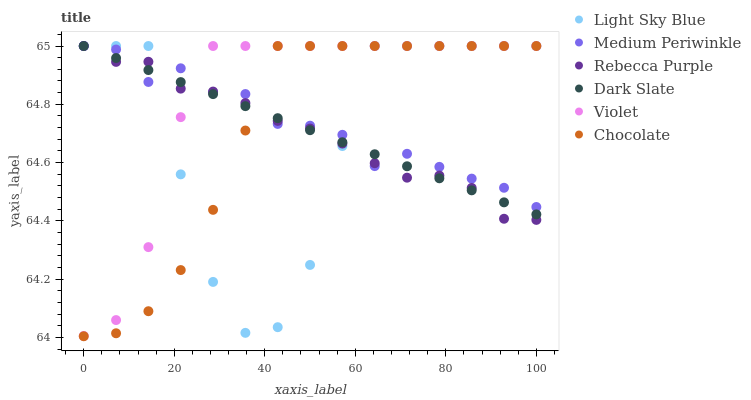Does Light Sky Blue have the minimum area under the curve?
Answer yes or no. Yes. Does Violet have the maximum area under the curve?
Answer yes or no. Yes. Does Chocolate have the minimum area under the curve?
Answer yes or no. No. Does Chocolate have the maximum area under the curve?
Answer yes or no. No. Is Dark Slate the smoothest?
Answer yes or no. Yes. Is Light Sky Blue the roughest?
Answer yes or no. Yes. Is Chocolate the smoothest?
Answer yes or no. No. Is Chocolate the roughest?
Answer yes or no. No. Does Chocolate have the lowest value?
Answer yes or no. Yes. Does Dark Slate have the lowest value?
Answer yes or no. No. Does Violet have the highest value?
Answer yes or no. Yes. Does Chocolate intersect Medium Periwinkle?
Answer yes or no. Yes. Is Chocolate less than Medium Periwinkle?
Answer yes or no. No. Is Chocolate greater than Medium Periwinkle?
Answer yes or no. No. 